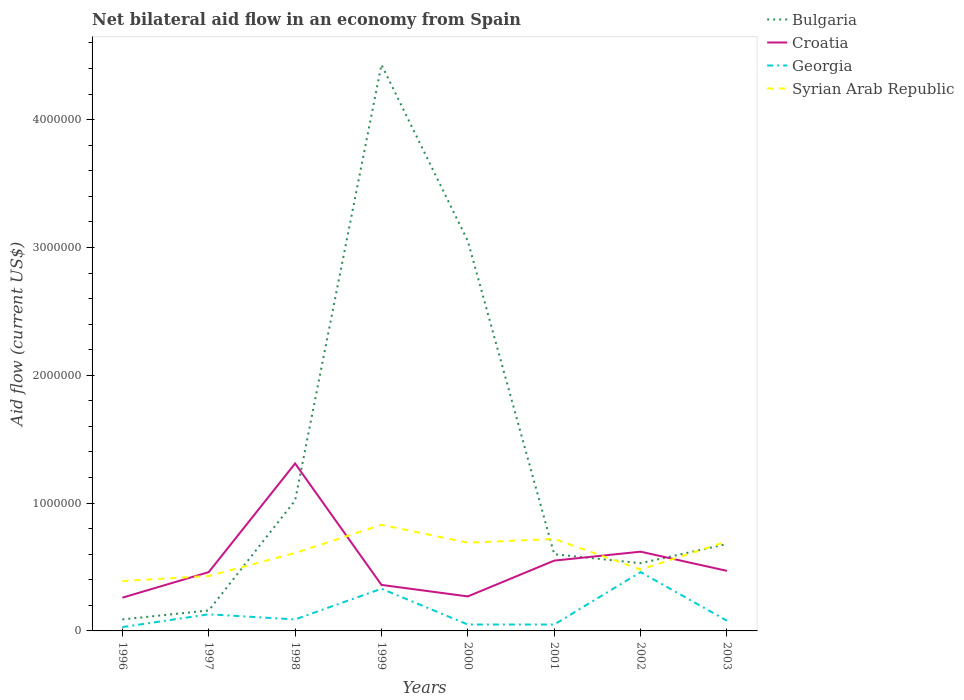Across all years, what is the maximum net bilateral aid flow in Bulgaria?
Ensure brevity in your answer.  9.00e+04. What is the difference between the highest and the second highest net bilateral aid flow in Bulgaria?
Provide a short and direct response. 4.34e+06. Is the net bilateral aid flow in Croatia strictly greater than the net bilateral aid flow in Syrian Arab Republic over the years?
Ensure brevity in your answer.  No. How many years are there in the graph?
Offer a very short reply. 8. Are the values on the major ticks of Y-axis written in scientific E-notation?
Keep it short and to the point. No. Does the graph contain any zero values?
Make the answer very short. No. Does the graph contain grids?
Provide a succinct answer. No. Where does the legend appear in the graph?
Offer a very short reply. Top right. How many legend labels are there?
Give a very brief answer. 4. How are the legend labels stacked?
Keep it short and to the point. Vertical. What is the title of the graph?
Keep it short and to the point. Net bilateral aid flow in an economy from Spain. Does "Middle income" appear as one of the legend labels in the graph?
Make the answer very short. No. What is the Aid flow (current US$) in Bulgaria in 1996?
Make the answer very short. 9.00e+04. What is the Aid flow (current US$) of Croatia in 1996?
Provide a short and direct response. 2.60e+05. What is the Aid flow (current US$) in Bulgaria in 1997?
Keep it short and to the point. 1.60e+05. What is the Aid flow (current US$) in Croatia in 1997?
Provide a short and direct response. 4.60e+05. What is the Aid flow (current US$) in Georgia in 1997?
Ensure brevity in your answer.  1.30e+05. What is the Aid flow (current US$) of Syrian Arab Republic in 1997?
Provide a short and direct response. 4.30e+05. What is the Aid flow (current US$) in Bulgaria in 1998?
Ensure brevity in your answer.  1.02e+06. What is the Aid flow (current US$) in Croatia in 1998?
Make the answer very short. 1.31e+06. What is the Aid flow (current US$) in Georgia in 1998?
Your answer should be very brief. 9.00e+04. What is the Aid flow (current US$) in Bulgaria in 1999?
Provide a short and direct response. 4.43e+06. What is the Aid flow (current US$) of Syrian Arab Republic in 1999?
Offer a very short reply. 8.30e+05. What is the Aid flow (current US$) of Bulgaria in 2000?
Make the answer very short. 3.05e+06. What is the Aid flow (current US$) in Croatia in 2000?
Offer a terse response. 2.70e+05. What is the Aid flow (current US$) in Syrian Arab Republic in 2000?
Ensure brevity in your answer.  6.90e+05. What is the Aid flow (current US$) of Georgia in 2001?
Make the answer very short. 5.00e+04. What is the Aid flow (current US$) of Syrian Arab Republic in 2001?
Offer a very short reply. 7.20e+05. What is the Aid flow (current US$) of Bulgaria in 2002?
Offer a terse response. 5.30e+05. What is the Aid flow (current US$) of Croatia in 2002?
Give a very brief answer. 6.20e+05. What is the Aid flow (current US$) in Georgia in 2002?
Offer a terse response. 4.60e+05. What is the Aid flow (current US$) of Syrian Arab Republic in 2002?
Your answer should be compact. 4.80e+05. What is the Aid flow (current US$) of Bulgaria in 2003?
Give a very brief answer. 6.80e+05. What is the Aid flow (current US$) in Croatia in 2003?
Ensure brevity in your answer.  4.70e+05. What is the Aid flow (current US$) in Georgia in 2003?
Your response must be concise. 8.00e+04. Across all years, what is the maximum Aid flow (current US$) in Bulgaria?
Provide a succinct answer. 4.43e+06. Across all years, what is the maximum Aid flow (current US$) of Croatia?
Give a very brief answer. 1.31e+06. Across all years, what is the maximum Aid flow (current US$) in Syrian Arab Republic?
Keep it short and to the point. 8.30e+05. Across all years, what is the minimum Aid flow (current US$) in Croatia?
Keep it short and to the point. 2.60e+05. Across all years, what is the minimum Aid flow (current US$) in Georgia?
Your response must be concise. 3.00e+04. What is the total Aid flow (current US$) in Bulgaria in the graph?
Keep it short and to the point. 1.06e+07. What is the total Aid flow (current US$) in Croatia in the graph?
Offer a terse response. 4.30e+06. What is the total Aid flow (current US$) in Georgia in the graph?
Your answer should be very brief. 1.22e+06. What is the total Aid flow (current US$) in Syrian Arab Republic in the graph?
Keep it short and to the point. 4.85e+06. What is the difference between the Aid flow (current US$) of Bulgaria in 1996 and that in 1997?
Provide a succinct answer. -7.00e+04. What is the difference between the Aid flow (current US$) in Croatia in 1996 and that in 1997?
Provide a succinct answer. -2.00e+05. What is the difference between the Aid flow (current US$) in Georgia in 1996 and that in 1997?
Offer a terse response. -1.00e+05. What is the difference between the Aid flow (current US$) in Syrian Arab Republic in 1996 and that in 1997?
Provide a succinct answer. -4.00e+04. What is the difference between the Aid flow (current US$) of Bulgaria in 1996 and that in 1998?
Ensure brevity in your answer.  -9.30e+05. What is the difference between the Aid flow (current US$) of Croatia in 1996 and that in 1998?
Offer a very short reply. -1.05e+06. What is the difference between the Aid flow (current US$) of Bulgaria in 1996 and that in 1999?
Offer a terse response. -4.34e+06. What is the difference between the Aid flow (current US$) in Syrian Arab Republic in 1996 and that in 1999?
Ensure brevity in your answer.  -4.40e+05. What is the difference between the Aid flow (current US$) of Bulgaria in 1996 and that in 2000?
Provide a short and direct response. -2.96e+06. What is the difference between the Aid flow (current US$) of Georgia in 1996 and that in 2000?
Your answer should be compact. -2.00e+04. What is the difference between the Aid flow (current US$) in Bulgaria in 1996 and that in 2001?
Ensure brevity in your answer.  -5.10e+05. What is the difference between the Aid flow (current US$) in Croatia in 1996 and that in 2001?
Give a very brief answer. -2.90e+05. What is the difference between the Aid flow (current US$) of Georgia in 1996 and that in 2001?
Keep it short and to the point. -2.00e+04. What is the difference between the Aid flow (current US$) of Syrian Arab Republic in 1996 and that in 2001?
Offer a terse response. -3.30e+05. What is the difference between the Aid flow (current US$) in Bulgaria in 1996 and that in 2002?
Provide a short and direct response. -4.40e+05. What is the difference between the Aid flow (current US$) of Croatia in 1996 and that in 2002?
Offer a very short reply. -3.60e+05. What is the difference between the Aid flow (current US$) of Georgia in 1996 and that in 2002?
Your answer should be compact. -4.30e+05. What is the difference between the Aid flow (current US$) of Bulgaria in 1996 and that in 2003?
Your answer should be very brief. -5.90e+05. What is the difference between the Aid flow (current US$) in Syrian Arab Republic in 1996 and that in 2003?
Your answer should be very brief. -3.10e+05. What is the difference between the Aid flow (current US$) of Bulgaria in 1997 and that in 1998?
Give a very brief answer. -8.60e+05. What is the difference between the Aid flow (current US$) in Croatia in 1997 and that in 1998?
Ensure brevity in your answer.  -8.50e+05. What is the difference between the Aid flow (current US$) in Bulgaria in 1997 and that in 1999?
Your response must be concise. -4.27e+06. What is the difference between the Aid flow (current US$) of Croatia in 1997 and that in 1999?
Ensure brevity in your answer.  1.00e+05. What is the difference between the Aid flow (current US$) in Syrian Arab Republic in 1997 and that in 1999?
Provide a short and direct response. -4.00e+05. What is the difference between the Aid flow (current US$) of Bulgaria in 1997 and that in 2000?
Provide a short and direct response. -2.89e+06. What is the difference between the Aid flow (current US$) in Croatia in 1997 and that in 2000?
Offer a terse response. 1.90e+05. What is the difference between the Aid flow (current US$) of Georgia in 1997 and that in 2000?
Ensure brevity in your answer.  8.00e+04. What is the difference between the Aid flow (current US$) of Bulgaria in 1997 and that in 2001?
Your answer should be compact. -4.40e+05. What is the difference between the Aid flow (current US$) in Syrian Arab Republic in 1997 and that in 2001?
Offer a terse response. -2.90e+05. What is the difference between the Aid flow (current US$) of Bulgaria in 1997 and that in 2002?
Ensure brevity in your answer.  -3.70e+05. What is the difference between the Aid flow (current US$) in Georgia in 1997 and that in 2002?
Offer a very short reply. -3.30e+05. What is the difference between the Aid flow (current US$) in Bulgaria in 1997 and that in 2003?
Your response must be concise. -5.20e+05. What is the difference between the Aid flow (current US$) of Croatia in 1997 and that in 2003?
Provide a short and direct response. -10000. What is the difference between the Aid flow (current US$) of Syrian Arab Republic in 1997 and that in 2003?
Provide a succinct answer. -2.70e+05. What is the difference between the Aid flow (current US$) of Bulgaria in 1998 and that in 1999?
Your answer should be compact. -3.41e+06. What is the difference between the Aid flow (current US$) in Croatia in 1998 and that in 1999?
Make the answer very short. 9.50e+05. What is the difference between the Aid flow (current US$) in Bulgaria in 1998 and that in 2000?
Give a very brief answer. -2.03e+06. What is the difference between the Aid flow (current US$) of Croatia in 1998 and that in 2000?
Ensure brevity in your answer.  1.04e+06. What is the difference between the Aid flow (current US$) in Georgia in 1998 and that in 2000?
Ensure brevity in your answer.  4.00e+04. What is the difference between the Aid flow (current US$) in Syrian Arab Republic in 1998 and that in 2000?
Ensure brevity in your answer.  -8.00e+04. What is the difference between the Aid flow (current US$) in Croatia in 1998 and that in 2001?
Your answer should be compact. 7.60e+05. What is the difference between the Aid flow (current US$) in Georgia in 1998 and that in 2001?
Give a very brief answer. 4.00e+04. What is the difference between the Aid flow (current US$) in Croatia in 1998 and that in 2002?
Provide a succinct answer. 6.90e+05. What is the difference between the Aid flow (current US$) of Georgia in 1998 and that in 2002?
Offer a very short reply. -3.70e+05. What is the difference between the Aid flow (current US$) in Bulgaria in 1998 and that in 2003?
Keep it short and to the point. 3.40e+05. What is the difference between the Aid flow (current US$) in Croatia in 1998 and that in 2003?
Ensure brevity in your answer.  8.40e+05. What is the difference between the Aid flow (current US$) of Syrian Arab Republic in 1998 and that in 2003?
Your response must be concise. -9.00e+04. What is the difference between the Aid flow (current US$) of Bulgaria in 1999 and that in 2000?
Give a very brief answer. 1.38e+06. What is the difference between the Aid flow (current US$) of Georgia in 1999 and that in 2000?
Ensure brevity in your answer.  2.80e+05. What is the difference between the Aid flow (current US$) in Syrian Arab Republic in 1999 and that in 2000?
Offer a terse response. 1.40e+05. What is the difference between the Aid flow (current US$) of Bulgaria in 1999 and that in 2001?
Your response must be concise. 3.83e+06. What is the difference between the Aid flow (current US$) in Croatia in 1999 and that in 2001?
Make the answer very short. -1.90e+05. What is the difference between the Aid flow (current US$) in Syrian Arab Republic in 1999 and that in 2001?
Offer a very short reply. 1.10e+05. What is the difference between the Aid flow (current US$) of Bulgaria in 1999 and that in 2002?
Your answer should be very brief. 3.90e+06. What is the difference between the Aid flow (current US$) of Croatia in 1999 and that in 2002?
Make the answer very short. -2.60e+05. What is the difference between the Aid flow (current US$) in Georgia in 1999 and that in 2002?
Your response must be concise. -1.30e+05. What is the difference between the Aid flow (current US$) in Syrian Arab Republic in 1999 and that in 2002?
Give a very brief answer. 3.50e+05. What is the difference between the Aid flow (current US$) of Bulgaria in 1999 and that in 2003?
Your answer should be very brief. 3.75e+06. What is the difference between the Aid flow (current US$) in Syrian Arab Republic in 1999 and that in 2003?
Provide a succinct answer. 1.30e+05. What is the difference between the Aid flow (current US$) in Bulgaria in 2000 and that in 2001?
Keep it short and to the point. 2.45e+06. What is the difference between the Aid flow (current US$) in Croatia in 2000 and that in 2001?
Provide a succinct answer. -2.80e+05. What is the difference between the Aid flow (current US$) in Georgia in 2000 and that in 2001?
Offer a very short reply. 0. What is the difference between the Aid flow (current US$) in Bulgaria in 2000 and that in 2002?
Offer a very short reply. 2.52e+06. What is the difference between the Aid flow (current US$) of Croatia in 2000 and that in 2002?
Provide a succinct answer. -3.50e+05. What is the difference between the Aid flow (current US$) in Georgia in 2000 and that in 2002?
Your answer should be compact. -4.10e+05. What is the difference between the Aid flow (current US$) in Bulgaria in 2000 and that in 2003?
Your answer should be very brief. 2.37e+06. What is the difference between the Aid flow (current US$) of Georgia in 2000 and that in 2003?
Your response must be concise. -3.00e+04. What is the difference between the Aid flow (current US$) in Syrian Arab Republic in 2000 and that in 2003?
Provide a short and direct response. -10000. What is the difference between the Aid flow (current US$) in Bulgaria in 2001 and that in 2002?
Ensure brevity in your answer.  7.00e+04. What is the difference between the Aid flow (current US$) in Croatia in 2001 and that in 2002?
Keep it short and to the point. -7.00e+04. What is the difference between the Aid flow (current US$) in Georgia in 2001 and that in 2002?
Offer a very short reply. -4.10e+05. What is the difference between the Aid flow (current US$) of Syrian Arab Republic in 2001 and that in 2002?
Your response must be concise. 2.40e+05. What is the difference between the Aid flow (current US$) of Georgia in 2001 and that in 2003?
Give a very brief answer. -3.00e+04. What is the difference between the Aid flow (current US$) of Syrian Arab Republic in 2001 and that in 2003?
Ensure brevity in your answer.  2.00e+04. What is the difference between the Aid flow (current US$) of Bulgaria in 2002 and that in 2003?
Keep it short and to the point. -1.50e+05. What is the difference between the Aid flow (current US$) in Georgia in 2002 and that in 2003?
Your response must be concise. 3.80e+05. What is the difference between the Aid flow (current US$) of Syrian Arab Republic in 2002 and that in 2003?
Your answer should be very brief. -2.20e+05. What is the difference between the Aid flow (current US$) of Bulgaria in 1996 and the Aid flow (current US$) of Croatia in 1997?
Keep it short and to the point. -3.70e+05. What is the difference between the Aid flow (current US$) in Bulgaria in 1996 and the Aid flow (current US$) in Georgia in 1997?
Keep it short and to the point. -4.00e+04. What is the difference between the Aid flow (current US$) in Croatia in 1996 and the Aid flow (current US$) in Georgia in 1997?
Provide a short and direct response. 1.30e+05. What is the difference between the Aid flow (current US$) of Georgia in 1996 and the Aid flow (current US$) of Syrian Arab Republic in 1997?
Keep it short and to the point. -4.00e+05. What is the difference between the Aid flow (current US$) in Bulgaria in 1996 and the Aid flow (current US$) in Croatia in 1998?
Offer a terse response. -1.22e+06. What is the difference between the Aid flow (current US$) of Bulgaria in 1996 and the Aid flow (current US$) of Syrian Arab Republic in 1998?
Offer a terse response. -5.20e+05. What is the difference between the Aid flow (current US$) in Croatia in 1996 and the Aid flow (current US$) in Georgia in 1998?
Offer a terse response. 1.70e+05. What is the difference between the Aid flow (current US$) in Croatia in 1996 and the Aid flow (current US$) in Syrian Arab Republic in 1998?
Offer a terse response. -3.50e+05. What is the difference between the Aid flow (current US$) of Georgia in 1996 and the Aid flow (current US$) of Syrian Arab Republic in 1998?
Keep it short and to the point. -5.80e+05. What is the difference between the Aid flow (current US$) of Bulgaria in 1996 and the Aid flow (current US$) of Croatia in 1999?
Offer a terse response. -2.70e+05. What is the difference between the Aid flow (current US$) in Bulgaria in 1996 and the Aid flow (current US$) in Syrian Arab Republic in 1999?
Your response must be concise. -7.40e+05. What is the difference between the Aid flow (current US$) of Croatia in 1996 and the Aid flow (current US$) of Georgia in 1999?
Your answer should be compact. -7.00e+04. What is the difference between the Aid flow (current US$) in Croatia in 1996 and the Aid flow (current US$) in Syrian Arab Republic in 1999?
Ensure brevity in your answer.  -5.70e+05. What is the difference between the Aid flow (current US$) of Georgia in 1996 and the Aid flow (current US$) of Syrian Arab Republic in 1999?
Provide a short and direct response. -8.00e+05. What is the difference between the Aid flow (current US$) in Bulgaria in 1996 and the Aid flow (current US$) in Syrian Arab Republic in 2000?
Offer a terse response. -6.00e+05. What is the difference between the Aid flow (current US$) in Croatia in 1996 and the Aid flow (current US$) in Syrian Arab Republic in 2000?
Your response must be concise. -4.30e+05. What is the difference between the Aid flow (current US$) of Georgia in 1996 and the Aid flow (current US$) of Syrian Arab Republic in 2000?
Your answer should be compact. -6.60e+05. What is the difference between the Aid flow (current US$) of Bulgaria in 1996 and the Aid flow (current US$) of Croatia in 2001?
Ensure brevity in your answer.  -4.60e+05. What is the difference between the Aid flow (current US$) of Bulgaria in 1996 and the Aid flow (current US$) of Syrian Arab Republic in 2001?
Offer a terse response. -6.30e+05. What is the difference between the Aid flow (current US$) in Croatia in 1996 and the Aid flow (current US$) in Syrian Arab Republic in 2001?
Your answer should be very brief. -4.60e+05. What is the difference between the Aid flow (current US$) in Georgia in 1996 and the Aid flow (current US$) in Syrian Arab Republic in 2001?
Provide a succinct answer. -6.90e+05. What is the difference between the Aid flow (current US$) in Bulgaria in 1996 and the Aid flow (current US$) in Croatia in 2002?
Your response must be concise. -5.30e+05. What is the difference between the Aid flow (current US$) in Bulgaria in 1996 and the Aid flow (current US$) in Georgia in 2002?
Your answer should be compact. -3.70e+05. What is the difference between the Aid flow (current US$) in Bulgaria in 1996 and the Aid flow (current US$) in Syrian Arab Republic in 2002?
Your answer should be compact. -3.90e+05. What is the difference between the Aid flow (current US$) in Croatia in 1996 and the Aid flow (current US$) in Georgia in 2002?
Keep it short and to the point. -2.00e+05. What is the difference between the Aid flow (current US$) in Georgia in 1996 and the Aid flow (current US$) in Syrian Arab Republic in 2002?
Your response must be concise. -4.50e+05. What is the difference between the Aid flow (current US$) in Bulgaria in 1996 and the Aid flow (current US$) in Croatia in 2003?
Keep it short and to the point. -3.80e+05. What is the difference between the Aid flow (current US$) of Bulgaria in 1996 and the Aid flow (current US$) of Georgia in 2003?
Provide a succinct answer. 10000. What is the difference between the Aid flow (current US$) of Bulgaria in 1996 and the Aid flow (current US$) of Syrian Arab Republic in 2003?
Offer a terse response. -6.10e+05. What is the difference between the Aid flow (current US$) in Croatia in 1996 and the Aid flow (current US$) in Georgia in 2003?
Give a very brief answer. 1.80e+05. What is the difference between the Aid flow (current US$) in Croatia in 1996 and the Aid flow (current US$) in Syrian Arab Republic in 2003?
Your response must be concise. -4.40e+05. What is the difference between the Aid flow (current US$) in Georgia in 1996 and the Aid flow (current US$) in Syrian Arab Republic in 2003?
Provide a succinct answer. -6.70e+05. What is the difference between the Aid flow (current US$) in Bulgaria in 1997 and the Aid flow (current US$) in Croatia in 1998?
Provide a short and direct response. -1.15e+06. What is the difference between the Aid flow (current US$) of Bulgaria in 1997 and the Aid flow (current US$) of Syrian Arab Republic in 1998?
Make the answer very short. -4.50e+05. What is the difference between the Aid flow (current US$) in Croatia in 1997 and the Aid flow (current US$) in Syrian Arab Republic in 1998?
Provide a succinct answer. -1.50e+05. What is the difference between the Aid flow (current US$) in Georgia in 1997 and the Aid flow (current US$) in Syrian Arab Republic in 1998?
Keep it short and to the point. -4.80e+05. What is the difference between the Aid flow (current US$) of Bulgaria in 1997 and the Aid flow (current US$) of Croatia in 1999?
Make the answer very short. -2.00e+05. What is the difference between the Aid flow (current US$) of Bulgaria in 1997 and the Aid flow (current US$) of Georgia in 1999?
Provide a short and direct response. -1.70e+05. What is the difference between the Aid flow (current US$) in Bulgaria in 1997 and the Aid flow (current US$) in Syrian Arab Republic in 1999?
Make the answer very short. -6.70e+05. What is the difference between the Aid flow (current US$) in Croatia in 1997 and the Aid flow (current US$) in Georgia in 1999?
Your answer should be compact. 1.30e+05. What is the difference between the Aid flow (current US$) of Croatia in 1997 and the Aid flow (current US$) of Syrian Arab Republic in 1999?
Your response must be concise. -3.70e+05. What is the difference between the Aid flow (current US$) in Georgia in 1997 and the Aid flow (current US$) in Syrian Arab Republic in 1999?
Provide a short and direct response. -7.00e+05. What is the difference between the Aid flow (current US$) of Bulgaria in 1997 and the Aid flow (current US$) of Syrian Arab Republic in 2000?
Make the answer very short. -5.30e+05. What is the difference between the Aid flow (current US$) in Croatia in 1997 and the Aid flow (current US$) in Syrian Arab Republic in 2000?
Give a very brief answer. -2.30e+05. What is the difference between the Aid flow (current US$) in Georgia in 1997 and the Aid flow (current US$) in Syrian Arab Republic in 2000?
Keep it short and to the point. -5.60e+05. What is the difference between the Aid flow (current US$) of Bulgaria in 1997 and the Aid flow (current US$) of Croatia in 2001?
Your response must be concise. -3.90e+05. What is the difference between the Aid flow (current US$) of Bulgaria in 1997 and the Aid flow (current US$) of Syrian Arab Republic in 2001?
Your answer should be very brief. -5.60e+05. What is the difference between the Aid flow (current US$) of Croatia in 1997 and the Aid flow (current US$) of Syrian Arab Republic in 2001?
Provide a short and direct response. -2.60e+05. What is the difference between the Aid flow (current US$) in Georgia in 1997 and the Aid flow (current US$) in Syrian Arab Republic in 2001?
Offer a terse response. -5.90e+05. What is the difference between the Aid flow (current US$) of Bulgaria in 1997 and the Aid flow (current US$) of Croatia in 2002?
Make the answer very short. -4.60e+05. What is the difference between the Aid flow (current US$) of Bulgaria in 1997 and the Aid flow (current US$) of Georgia in 2002?
Your answer should be very brief. -3.00e+05. What is the difference between the Aid flow (current US$) in Bulgaria in 1997 and the Aid flow (current US$) in Syrian Arab Republic in 2002?
Keep it short and to the point. -3.20e+05. What is the difference between the Aid flow (current US$) in Croatia in 1997 and the Aid flow (current US$) in Georgia in 2002?
Ensure brevity in your answer.  0. What is the difference between the Aid flow (current US$) of Croatia in 1997 and the Aid flow (current US$) of Syrian Arab Republic in 2002?
Ensure brevity in your answer.  -2.00e+04. What is the difference between the Aid flow (current US$) of Georgia in 1997 and the Aid flow (current US$) of Syrian Arab Republic in 2002?
Provide a short and direct response. -3.50e+05. What is the difference between the Aid flow (current US$) in Bulgaria in 1997 and the Aid flow (current US$) in Croatia in 2003?
Ensure brevity in your answer.  -3.10e+05. What is the difference between the Aid flow (current US$) of Bulgaria in 1997 and the Aid flow (current US$) of Georgia in 2003?
Your answer should be compact. 8.00e+04. What is the difference between the Aid flow (current US$) in Bulgaria in 1997 and the Aid flow (current US$) in Syrian Arab Republic in 2003?
Provide a succinct answer. -5.40e+05. What is the difference between the Aid flow (current US$) in Croatia in 1997 and the Aid flow (current US$) in Syrian Arab Republic in 2003?
Your answer should be very brief. -2.40e+05. What is the difference between the Aid flow (current US$) in Georgia in 1997 and the Aid flow (current US$) in Syrian Arab Republic in 2003?
Give a very brief answer. -5.70e+05. What is the difference between the Aid flow (current US$) in Bulgaria in 1998 and the Aid flow (current US$) in Croatia in 1999?
Your response must be concise. 6.60e+05. What is the difference between the Aid flow (current US$) in Bulgaria in 1998 and the Aid flow (current US$) in Georgia in 1999?
Your answer should be very brief. 6.90e+05. What is the difference between the Aid flow (current US$) of Bulgaria in 1998 and the Aid flow (current US$) of Syrian Arab Republic in 1999?
Your response must be concise. 1.90e+05. What is the difference between the Aid flow (current US$) of Croatia in 1998 and the Aid flow (current US$) of Georgia in 1999?
Your answer should be compact. 9.80e+05. What is the difference between the Aid flow (current US$) of Croatia in 1998 and the Aid flow (current US$) of Syrian Arab Republic in 1999?
Offer a very short reply. 4.80e+05. What is the difference between the Aid flow (current US$) of Georgia in 1998 and the Aid flow (current US$) of Syrian Arab Republic in 1999?
Provide a succinct answer. -7.40e+05. What is the difference between the Aid flow (current US$) of Bulgaria in 1998 and the Aid flow (current US$) of Croatia in 2000?
Offer a very short reply. 7.50e+05. What is the difference between the Aid flow (current US$) in Bulgaria in 1998 and the Aid flow (current US$) in Georgia in 2000?
Your answer should be very brief. 9.70e+05. What is the difference between the Aid flow (current US$) of Bulgaria in 1998 and the Aid flow (current US$) of Syrian Arab Republic in 2000?
Offer a terse response. 3.30e+05. What is the difference between the Aid flow (current US$) of Croatia in 1998 and the Aid flow (current US$) of Georgia in 2000?
Provide a succinct answer. 1.26e+06. What is the difference between the Aid flow (current US$) in Croatia in 1998 and the Aid flow (current US$) in Syrian Arab Republic in 2000?
Provide a short and direct response. 6.20e+05. What is the difference between the Aid flow (current US$) of Georgia in 1998 and the Aid flow (current US$) of Syrian Arab Republic in 2000?
Provide a short and direct response. -6.00e+05. What is the difference between the Aid flow (current US$) of Bulgaria in 1998 and the Aid flow (current US$) of Georgia in 2001?
Offer a very short reply. 9.70e+05. What is the difference between the Aid flow (current US$) of Bulgaria in 1998 and the Aid flow (current US$) of Syrian Arab Republic in 2001?
Provide a succinct answer. 3.00e+05. What is the difference between the Aid flow (current US$) in Croatia in 1998 and the Aid flow (current US$) in Georgia in 2001?
Offer a terse response. 1.26e+06. What is the difference between the Aid flow (current US$) in Croatia in 1998 and the Aid flow (current US$) in Syrian Arab Republic in 2001?
Ensure brevity in your answer.  5.90e+05. What is the difference between the Aid flow (current US$) of Georgia in 1998 and the Aid flow (current US$) of Syrian Arab Republic in 2001?
Make the answer very short. -6.30e+05. What is the difference between the Aid flow (current US$) in Bulgaria in 1998 and the Aid flow (current US$) in Croatia in 2002?
Provide a succinct answer. 4.00e+05. What is the difference between the Aid flow (current US$) of Bulgaria in 1998 and the Aid flow (current US$) of Georgia in 2002?
Your answer should be very brief. 5.60e+05. What is the difference between the Aid flow (current US$) of Bulgaria in 1998 and the Aid flow (current US$) of Syrian Arab Republic in 2002?
Provide a succinct answer. 5.40e+05. What is the difference between the Aid flow (current US$) of Croatia in 1998 and the Aid flow (current US$) of Georgia in 2002?
Keep it short and to the point. 8.50e+05. What is the difference between the Aid flow (current US$) of Croatia in 1998 and the Aid flow (current US$) of Syrian Arab Republic in 2002?
Make the answer very short. 8.30e+05. What is the difference between the Aid flow (current US$) in Georgia in 1998 and the Aid flow (current US$) in Syrian Arab Republic in 2002?
Keep it short and to the point. -3.90e+05. What is the difference between the Aid flow (current US$) of Bulgaria in 1998 and the Aid flow (current US$) of Croatia in 2003?
Offer a terse response. 5.50e+05. What is the difference between the Aid flow (current US$) in Bulgaria in 1998 and the Aid flow (current US$) in Georgia in 2003?
Provide a short and direct response. 9.40e+05. What is the difference between the Aid flow (current US$) of Croatia in 1998 and the Aid flow (current US$) of Georgia in 2003?
Your answer should be very brief. 1.23e+06. What is the difference between the Aid flow (current US$) of Croatia in 1998 and the Aid flow (current US$) of Syrian Arab Republic in 2003?
Keep it short and to the point. 6.10e+05. What is the difference between the Aid flow (current US$) of Georgia in 1998 and the Aid flow (current US$) of Syrian Arab Republic in 2003?
Ensure brevity in your answer.  -6.10e+05. What is the difference between the Aid flow (current US$) in Bulgaria in 1999 and the Aid flow (current US$) in Croatia in 2000?
Your answer should be very brief. 4.16e+06. What is the difference between the Aid flow (current US$) of Bulgaria in 1999 and the Aid flow (current US$) of Georgia in 2000?
Keep it short and to the point. 4.38e+06. What is the difference between the Aid flow (current US$) of Bulgaria in 1999 and the Aid flow (current US$) of Syrian Arab Republic in 2000?
Keep it short and to the point. 3.74e+06. What is the difference between the Aid flow (current US$) in Croatia in 1999 and the Aid flow (current US$) in Syrian Arab Republic in 2000?
Your answer should be compact. -3.30e+05. What is the difference between the Aid flow (current US$) of Georgia in 1999 and the Aid flow (current US$) of Syrian Arab Republic in 2000?
Ensure brevity in your answer.  -3.60e+05. What is the difference between the Aid flow (current US$) in Bulgaria in 1999 and the Aid flow (current US$) in Croatia in 2001?
Keep it short and to the point. 3.88e+06. What is the difference between the Aid flow (current US$) in Bulgaria in 1999 and the Aid flow (current US$) in Georgia in 2001?
Offer a very short reply. 4.38e+06. What is the difference between the Aid flow (current US$) in Bulgaria in 1999 and the Aid flow (current US$) in Syrian Arab Republic in 2001?
Provide a short and direct response. 3.71e+06. What is the difference between the Aid flow (current US$) of Croatia in 1999 and the Aid flow (current US$) of Syrian Arab Republic in 2001?
Make the answer very short. -3.60e+05. What is the difference between the Aid flow (current US$) in Georgia in 1999 and the Aid flow (current US$) in Syrian Arab Republic in 2001?
Your answer should be very brief. -3.90e+05. What is the difference between the Aid flow (current US$) of Bulgaria in 1999 and the Aid flow (current US$) of Croatia in 2002?
Your response must be concise. 3.81e+06. What is the difference between the Aid flow (current US$) in Bulgaria in 1999 and the Aid flow (current US$) in Georgia in 2002?
Keep it short and to the point. 3.97e+06. What is the difference between the Aid flow (current US$) of Bulgaria in 1999 and the Aid flow (current US$) of Syrian Arab Republic in 2002?
Offer a very short reply. 3.95e+06. What is the difference between the Aid flow (current US$) of Croatia in 1999 and the Aid flow (current US$) of Georgia in 2002?
Provide a short and direct response. -1.00e+05. What is the difference between the Aid flow (current US$) of Croatia in 1999 and the Aid flow (current US$) of Syrian Arab Republic in 2002?
Provide a succinct answer. -1.20e+05. What is the difference between the Aid flow (current US$) in Bulgaria in 1999 and the Aid flow (current US$) in Croatia in 2003?
Give a very brief answer. 3.96e+06. What is the difference between the Aid flow (current US$) of Bulgaria in 1999 and the Aid flow (current US$) of Georgia in 2003?
Keep it short and to the point. 4.35e+06. What is the difference between the Aid flow (current US$) of Bulgaria in 1999 and the Aid flow (current US$) of Syrian Arab Republic in 2003?
Offer a terse response. 3.73e+06. What is the difference between the Aid flow (current US$) of Croatia in 1999 and the Aid flow (current US$) of Georgia in 2003?
Ensure brevity in your answer.  2.80e+05. What is the difference between the Aid flow (current US$) in Georgia in 1999 and the Aid flow (current US$) in Syrian Arab Republic in 2003?
Make the answer very short. -3.70e+05. What is the difference between the Aid flow (current US$) of Bulgaria in 2000 and the Aid flow (current US$) of Croatia in 2001?
Give a very brief answer. 2.50e+06. What is the difference between the Aid flow (current US$) in Bulgaria in 2000 and the Aid flow (current US$) in Georgia in 2001?
Ensure brevity in your answer.  3.00e+06. What is the difference between the Aid flow (current US$) in Bulgaria in 2000 and the Aid flow (current US$) in Syrian Arab Republic in 2001?
Offer a very short reply. 2.33e+06. What is the difference between the Aid flow (current US$) in Croatia in 2000 and the Aid flow (current US$) in Georgia in 2001?
Make the answer very short. 2.20e+05. What is the difference between the Aid flow (current US$) of Croatia in 2000 and the Aid flow (current US$) of Syrian Arab Republic in 2001?
Offer a terse response. -4.50e+05. What is the difference between the Aid flow (current US$) in Georgia in 2000 and the Aid flow (current US$) in Syrian Arab Republic in 2001?
Give a very brief answer. -6.70e+05. What is the difference between the Aid flow (current US$) of Bulgaria in 2000 and the Aid flow (current US$) of Croatia in 2002?
Your answer should be very brief. 2.43e+06. What is the difference between the Aid flow (current US$) of Bulgaria in 2000 and the Aid flow (current US$) of Georgia in 2002?
Ensure brevity in your answer.  2.59e+06. What is the difference between the Aid flow (current US$) in Bulgaria in 2000 and the Aid flow (current US$) in Syrian Arab Republic in 2002?
Provide a short and direct response. 2.57e+06. What is the difference between the Aid flow (current US$) of Georgia in 2000 and the Aid flow (current US$) of Syrian Arab Republic in 2002?
Offer a terse response. -4.30e+05. What is the difference between the Aid flow (current US$) of Bulgaria in 2000 and the Aid flow (current US$) of Croatia in 2003?
Give a very brief answer. 2.58e+06. What is the difference between the Aid flow (current US$) in Bulgaria in 2000 and the Aid flow (current US$) in Georgia in 2003?
Provide a short and direct response. 2.97e+06. What is the difference between the Aid flow (current US$) in Bulgaria in 2000 and the Aid flow (current US$) in Syrian Arab Republic in 2003?
Give a very brief answer. 2.35e+06. What is the difference between the Aid flow (current US$) in Croatia in 2000 and the Aid flow (current US$) in Syrian Arab Republic in 2003?
Keep it short and to the point. -4.30e+05. What is the difference between the Aid flow (current US$) of Georgia in 2000 and the Aid flow (current US$) of Syrian Arab Republic in 2003?
Offer a very short reply. -6.50e+05. What is the difference between the Aid flow (current US$) of Georgia in 2001 and the Aid flow (current US$) of Syrian Arab Republic in 2002?
Give a very brief answer. -4.30e+05. What is the difference between the Aid flow (current US$) of Bulgaria in 2001 and the Aid flow (current US$) of Croatia in 2003?
Ensure brevity in your answer.  1.30e+05. What is the difference between the Aid flow (current US$) in Bulgaria in 2001 and the Aid flow (current US$) in Georgia in 2003?
Give a very brief answer. 5.20e+05. What is the difference between the Aid flow (current US$) in Croatia in 2001 and the Aid flow (current US$) in Georgia in 2003?
Your answer should be compact. 4.70e+05. What is the difference between the Aid flow (current US$) of Croatia in 2001 and the Aid flow (current US$) of Syrian Arab Republic in 2003?
Keep it short and to the point. -1.50e+05. What is the difference between the Aid flow (current US$) of Georgia in 2001 and the Aid flow (current US$) of Syrian Arab Republic in 2003?
Your answer should be compact. -6.50e+05. What is the difference between the Aid flow (current US$) of Bulgaria in 2002 and the Aid flow (current US$) of Croatia in 2003?
Offer a terse response. 6.00e+04. What is the difference between the Aid flow (current US$) in Bulgaria in 2002 and the Aid flow (current US$) in Georgia in 2003?
Offer a terse response. 4.50e+05. What is the difference between the Aid flow (current US$) in Bulgaria in 2002 and the Aid flow (current US$) in Syrian Arab Republic in 2003?
Ensure brevity in your answer.  -1.70e+05. What is the difference between the Aid flow (current US$) of Croatia in 2002 and the Aid flow (current US$) of Georgia in 2003?
Your answer should be compact. 5.40e+05. What is the average Aid flow (current US$) of Bulgaria per year?
Offer a terse response. 1.32e+06. What is the average Aid flow (current US$) of Croatia per year?
Your response must be concise. 5.38e+05. What is the average Aid flow (current US$) in Georgia per year?
Give a very brief answer. 1.52e+05. What is the average Aid flow (current US$) in Syrian Arab Republic per year?
Your response must be concise. 6.06e+05. In the year 1996, what is the difference between the Aid flow (current US$) of Bulgaria and Aid flow (current US$) of Croatia?
Ensure brevity in your answer.  -1.70e+05. In the year 1996, what is the difference between the Aid flow (current US$) of Bulgaria and Aid flow (current US$) of Georgia?
Give a very brief answer. 6.00e+04. In the year 1996, what is the difference between the Aid flow (current US$) in Croatia and Aid flow (current US$) in Syrian Arab Republic?
Offer a very short reply. -1.30e+05. In the year 1996, what is the difference between the Aid flow (current US$) in Georgia and Aid flow (current US$) in Syrian Arab Republic?
Provide a succinct answer. -3.60e+05. In the year 1997, what is the difference between the Aid flow (current US$) of Bulgaria and Aid flow (current US$) of Croatia?
Offer a very short reply. -3.00e+05. In the year 1997, what is the difference between the Aid flow (current US$) of Bulgaria and Aid flow (current US$) of Syrian Arab Republic?
Your answer should be compact. -2.70e+05. In the year 1997, what is the difference between the Aid flow (current US$) in Croatia and Aid flow (current US$) in Georgia?
Give a very brief answer. 3.30e+05. In the year 1998, what is the difference between the Aid flow (current US$) of Bulgaria and Aid flow (current US$) of Croatia?
Provide a short and direct response. -2.90e+05. In the year 1998, what is the difference between the Aid flow (current US$) of Bulgaria and Aid flow (current US$) of Georgia?
Make the answer very short. 9.30e+05. In the year 1998, what is the difference between the Aid flow (current US$) of Bulgaria and Aid flow (current US$) of Syrian Arab Republic?
Provide a succinct answer. 4.10e+05. In the year 1998, what is the difference between the Aid flow (current US$) in Croatia and Aid flow (current US$) in Georgia?
Make the answer very short. 1.22e+06. In the year 1998, what is the difference between the Aid flow (current US$) of Georgia and Aid flow (current US$) of Syrian Arab Republic?
Make the answer very short. -5.20e+05. In the year 1999, what is the difference between the Aid flow (current US$) in Bulgaria and Aid flow (current US$) in Croatia?
Offer a terse response. 4.07e+06. In the year 1999, what is the difference between the Aid flow (current US$) in Bulgaria and Aid flow (current US$) in Georgia?
Provide a short and direct response. 4.10e+06. In the year 1999, what is the difference between the Aid flow (current US$) in Bulgaria and Aid flow (current US$) in Syrian Arab Republic?
Make the answer very short. 3.60e+06. In the year 1999, what is the difference between the Aid flow (current US$) in Croatia and Aid flow (current US$) in Syrian Arab Republic?
Give a very brief answer. -4.70e+05. In the year 1999, what is the difference between the Aid flow (current US$) of Georgia and Aid flow (current US$) of Syrian Arab Republic?
Your response must be concise. -5.00e+05. In the year 2000, what is the difference between the Aid flow (current US$) of Bulgaria and Aid flow (current US$) of Croatia?
Your answer should be very brief. 2.78e+06. In the year 2000, what is the difference between the Aid flow (current US$) in Bulgaria and Aid flow (current US$) in Georgia?
Offer a terse response. 3.00e+06. In the year 2000, what is the difference between the Aid flow (current US$) of Bulgaria and Aid flow (current US$) of Syrian Arab Republic?
Provide a succinct answer. 2.36e+06. In the year 2000, what is the difference between the Aid flow (current US$) of Croatia and Aid flow (current US$) of Syrian Arab Republic?
Offer a terse response. -4.20e+05. In the year 2000, what is the difference between the Aid flow (current US$) of Georgia and Aid flow (current US$) of Syrian Arab Republic?
Ensure brevity in your answer.  -6.40e+05. In the year 2001, what is the difference between the Aid flow (current US$) of Bulgaria and Aid flow (current US$) of Croatia?
Your answer should be very brief. 5.00e+04. In the year 2001, what is the difference between the Aid flow (current US$) in Bulgaria and Aid flow (current US$) in Georgia?
Your answer should be compact. 5.50e+05. In the year 2001, what is the difference between the Aid flow (current US$) in Croatia and Aid flow (current US$) in Georgia?
Keep it short and to the point. 5.00e+05. In the year 2001, what is the difference between the Aid flow (current US$) in Croatia and Aid flow (current US$) in Syrian Arab Republic?
Provide a succinct answer. -1.70e+05. In the year 2001, what is the difference between the Aid flow (current US$) of Georgia and Aid flow (current US$) of Syrian Arab Republic?
Provide a succinct answer. -6.70e+05. In the year 2002, what is the difference between the Aid flow (current US$) in Bulgaria and Aid flow (current US$) in Georgia?
Your response must be concise. 7.00e+04. In the year 2003, what is the difference between the Aid flow (current US$) of Bulgaria and Aid flow (current US$) of Georgia?
Keep it short and to the point. 6.00e+05. In the year 2003, what is the difference between the Aid flow (current US$) in Croatia and Aid flow (current US$) in Georgia?
Ensure brevity in your answer.  3.90e+05. In the year 2003, what is the difference between the Aid flow (current US$) in Croatia and Aid flow (current US$) in Syrian Arab Republic?
Offer a very short reply. -2.30e+05. In the year 2003, what is the difference between the Aid flow (current US$) in Georgia and Aid flow (current US$) in Syrian Arab Republic?
Your response must be concise. -6.20e+05. What is the ratio of the Aid flow (current US$) of Bulgaria in 1996 to that in 1997?
Offer a terse response. 0.56. What is the ratio of the Aid flow (current US$) of Croatia in 1996 to that in 1997?
Your answer should be very brief. 0.57. What is the ratio of the Aid flow (current US$) of Georgia in 1996 to that in 1997?
Ensure brevity in your answer.  0.23. What is the ratio of the Aid flow (current US$) in Syrian Arab Republic in 1996 to that in 1997?
Your response must be concise. 0.91. What is the ratio of the Aid flow (current US$) of Bulgaria in 1996 to that in 1998?
Your answer should be very brief. 0.09. What is the ratio of the Aid flow (current US$) of Croatia in 1996 to that in 1998?
Make the answer very short. 0.2. What is the ratio of the Aid flow (current US$) in Syrian Arab Republic in 1996 to that in 1998?
Your response must be concise. 0.64. What is the ratio of the Aid flow (current US$) of Bulgaria in 1996 to that in 1999?
Your response must be concise. 0.02. What is the ratio of the Aid flow (current US$) of Croatia in 1996 to that in 1999?
Your response must be concise. 0.72. What is the ratio of the Aid flow (current US$) in Georgia in 1996 to that in 1999?
Keep it short and to the point. 0.09. What is the ratio of the Aid flow (current US$) in Syrian Arab Republic in 1996 to that in 1999?
Ensure brevity in your answer.  0.47. What is the ratio of the Aid flow (current US$) of Bulgaria in 1996 to that in 2000?
Give a very brief answer. 0.03. What is the ratio of the Aid flow (current US$) of Syrian Arab Republic in 1996 to that in 2000?
Keep it short and to the point. 0.57. What is the ratio of the Aid flow (current US$) in Croatia in 1996 to that in 2001?
Your answer should be very brief. 0.47. What is the ratio of the Aid flow (current US$) of Syrian Arab Republic in 1996 to that in 2001?
Make the answer very short. 0.54. What is the ratio of the Aid flow (current US$) of Bulgaria in 1996 to that in 2002?
Keep it short and to the point. 0.17. What is the ratio of the Aid flow (current US$) in Croatia in 1996 to that in 2002?
Your answer should be very brief. 0.42. What is the ratio of the Aid flow (current US$) in Georgia in 1996 to that in 2002?
Provide a short and direct response. 0.07. What is the ratio of the Aid flow (current US$) in Syrian Arab Republic in 1996 to that in 2002?
Offer a terse response. 0.81. What is the ratio of the Aid flow (current US$) in Bulgaria in 1996 to that in 2003?
Offer a terse response. 0.13. What is the ratio of the Aid flow (current US$) of Croatia in 1996 to that in 2003?
Your answer should be compact. 0.55. What is the ratio of the Aid flow (current US$) of Syrian Arab Republic in 1996 to that in 2003?
Keep it short and to the point. 0.56. What is the ratio of the Aid flow (current US$) in Bulgaria in 1997 to that in 1998?
Provide a succinct answer. 0.16. What is the ratio of the Aid flow (current US$) in Croatia in 1997 to that in 1998?
Provide a short and direct response. 0.35. What is the ratio of the Aid flow (current US$) in Georgia in 1997 to that in 1998?
Provide a short and direct response. 1.44. What is the ratio of the Aid flow (current US$) in Syrian Arab Republic in 1997 to that in 1998?
Make the answer very short. 0.7. What is the ratio of the Aid flow (current US$) of Bulgaria in 1997 to that in 1999?
Offer a terse response. 0.04. What is the ratio of the Aid flow (current US$) in Croatia in 1997 to that in 1999?
Provide a succinct answer. 1.28. What is the ratio of the Aid flow (current US$) of Georgia in 1997 to that in 1999?
Keep it short and to the point. 0.39. What is the ratio of the Aid flow (current US$) of Syrian Arab Republic in 1997 to that in 1999?
Your response must be concise. 0.52. What is the ratio of the Aid flow (current US$) in Bulgaria in 1997 to that in 2000?
Offer a very short reply. 0.05. What is the ratio of the Aid flow (current US$) in Croatia in 1997 to that in 2000?
Offer a terse response. 1.7. What is the ratio of the Aid flow (current US$) in Georgia in 1997 to that in 2000?
Your answer should be compact. 2.6. What is the ratio of the Aid flow (current US$) in Syrian Arab Republic in 1997 to that in 2000?
Ensure brevity in your answer.  0.62. What is the ratio of the Aid flow (current US$) of Bulgaria in 1997 to that in 2001?
Make the answer very short. 0.27. What is the ratio of the Aid flow (current US$) of Croatia in 1997 to that in 2001?
Provide a short and direct response. 0.84. What is the ratio of the Aid flow (current US$) in Georgia in 1997 to that in 2001?
Your answer should be compact. 2.6. What is the ratio of the Aid flow (current US$) of Syrian Arab Republic in 1997 to that in 2001?
Make the answer very short. 0.6. What is the ratio of the Aid flow (current US$) of Bulgaria in 1997 to that in 2002?
Offer a very short reply. 0.3. What is the ratio of the Aid flow (current US$) in Croatia in 1997 to that in 2002?
Offer a terse response. 0.74. What is the ratio of the Aid flow (current US$) of Georgia in 1997 to that in 2002?
Provide a short and direct response. 0.28. What is the ratio of the Aid flow (current US$) in Syrian Arab Republic in 1997 to that in 2002?
Ensure brevity in your answer.  0.9. What is the ratio of the Aid flow (current US$) in Bulgaria in 1997 to that in 2003?
Your answer should be very brief. 0.24. What is the ratio of the Aid flow (current US$) of Croatia in 1997 to that in 2003?
Provide a short and direct response. 0.98. What is the ratio of the Aid flow (current US$) in Georgia in 1997 to that in 2003?
Make the answer very short. 1.62. What is the ratio of the Aid flow (current US$) in Syrian Arab Republic in 1997 to that in 2003?
Your answer should be compact. 0.61. What is the ratio of the Aid flow (current US$) in Bulgaria in 1998 to that in 1999?
Give a very brief answer. 0.23. What is the ratio of the Aid flow (current US$) in Croatia in 1998 to that in 1999?
Provide a succinct answer. 3.64. What is the ratio of the Aid flow (current US$) in Georgia in 1998 to that in 1999?
Offer a terse response. 0.27. What is the ratio of the Aid flow (current US$) of Syrian Arab Republic in 1998 to that in 1999?
Offer a terse response. 0.73. What is the ratio of the Aid flow (current US$) in Bulgaria in 1998 to that in 2000?
Your answer should be compact. 0.33. What is the ratio of the Aid flow (current US$) of Croatia in 1998 to that in 2000?
Make the answer very short. 4.85. What is the ratio of the Aid flow (current US$) of Syrian Arab Republic in 1998 to that in 2000?
Your answer should be very brief. 0.88. What is the ratio of the Aid flow (current US$) in Bulgaria in 1998 to that in 2001?
Your answer should be compact. 1.7. What is the ratio of the Aid flow (current US$) of Croatia in 1998 to that in 2001?
Your answer should be compact. 2.38. What is the ratio of the Aid flow (current US$) in Syrian Arab Republic in 1998 to that in 2001?
Give a very brief answer. 0.85. What is the ratio of the Aid flow (current US$) of Bulgaria in 1998 to that in 2002?
Provide a short and direct response. 1.92. What is the ratio of the Aid flow (current US$) in Croatia in 1998 to that in 2002?
Your answer should be compact. 2.11. What is the ratio of the Aid flow (current US$) in Georgia in 1998 to that in 2002?
Make the answer very short. 0.2. What is the ratio of the Aid flow (current US$) in Syrian Arab Republic in 1998 to that in 2002?
Your response must be concise. 1.27. What is the ratio of the Aid flow (current US$) of Croatia in 1998 to that in 2003?
Your answer should be very brief. 2.79. What is the ratio of the Aid flow (current US$) of Georgia in 1998 to that in 2003?
Your answer should be very brief. 1.12. What is the ratio of the Aid flow (current US$) of Syrian Arab Republic in 1998 to that in 2003?
Ensure brevity in your answer.  0.87. What is the ratio of the Aid flow (current US$) of Bulgaria in 1999 to that in 2000?
Keep it short and to the point. 1.45. What is the ratio of the Aid flow (current US$) of Croatia in 1999 to that in 2000?
Keep it short and to the point. 1.33. What is the ratio of the Aid flow (current US$) of Georgia in 1999 to that in 2000?
Provide a short and direct response. 6.6. What is the ratio of the Aid flow (current US$) of Syrian Arab Republic in 1999 to that in 2000?
Offer a terse response. 1.2. What is the ratio of the Aid flow (current US$) in Bulgaria in 1999 to that in 2001?
Your answer should be very brief. 7.38. What is the ratio of the Aid flow (current US$) of Croatia in 1999 to that in 2001?
Your response must be concise. 0.65. What is the ratio of the Aid flow (current US$) of Syrian Arab Republic in 1999 to that in 2001?
Your answer should be very brief. 1.15. What is the ratio of the Aid flow (current US$) in Bulgaria in 1999 to that in 2002?
Offer a very short reply. 8.36. What is the ratio of the Aid flow (current US$) of Croatia in 1999 to that in 2002?
Make the answer very short. 0.58. What is the ratio of the Aid flow (current US$) in Georgia in 1999 to that in 2002?
Provide a succinct answer. 0.72. What is the ratio of the Aid flow (current US$) in Syrian Arab Republic in 1999 to that in 2002?
Your answer should be very brief. 1.73. What is the ratio of the Aid flow (current US$) in Bulgaria in 1999 to that in 2003?
Your answer should be compact. 6.51. What is the ratio of the Aid flow (current US$) of Croatia in 1999 to that in 2003?
Your answer should be compact. 0.77. What is the ratio of the Aid flow (current US$) in Georgia in 1999 to that in 2003?
Ensure brevity in your answer.  4.12. What is the ratio of the Aid flow (current US$) of Syrian Arab Republic in 1999 to that in 2003?
Keep it short and to the point. 1.19. What is the ratio of the Aid flow (current US$) in Bulgaria in 2000 to that in 2001?
Your response must be concise. 5.08. What is the ratio of the Aid flow (current US$) of Croatia in 2000 to that in 2001?
Ensure brevity in your answer.  0.49. What is the ratio of the Aid flow (current US$) of Georgia in 2000 to that in 2001?
Keep it short and to the point. 1. What is the ratio of the Aid flow (current US$) in Bulgaria in 2000 to that in 2002?
Provide a short and direct response. 5.75. What is the ratio of the Aid flow (current US$) of Croatia in 2000 to that in 2002?
Offer a very short reply. 0.44. What is the ratio of the Aid flow (current US$) in Georgia in 2000 to that in 2002?
Offer a very short reply. 0.11. What is the ratio of the Aid flow (current US$) of Syrian Arab Republic in 2000 to that in 2002?
Your response must be concise. 1.44. What is the ratio of the Aid flow (current US$) in Bulgaria in 2000 to that in 2003?
Make the answer very short. 4.49. What is the ratio of the Aid flow (current US$) of Croatia in 2000 to that in 2003?
Provide a succinct answer. 0.57. What is the ratio of the Aid flow (current US$) of Syrian Arab Republic in 2000 to that in 2003?
Your answer should be compact. 0.99. What is the ratio of the Aid flow (current US$) of Bulgaria in 2001 to that in 2002?
Make the answer very short. 1.13. What is the ratio of the Aid flow (current US$) of Croatia in 2001 to that in 2002?
Offer a terse response. 0.89. What is the ratio of the Aid flow (current US$) in Georgia in 2001 to that in 2002?
Keep it short and to the point. 0.11. What is the ratio of the Aid flow (current US$) in Bulgaria in 2001 to that in 2003?
Your response must be concise. 0.88. What is the ratio of the Aid flow (current US$) of Croatia in 2001 to that in 2003?
Keep it short and to the point. 1.17. What is the ratio of the Aid flow (current US$) in Georgia in 2001 to that in 2003?
Your answer should be compact. 0.62. What is the ratio of the Aid flow (current US$) of Syrian Arab Republic in 2001 to that in 2003?
Offer a terse response. 1.03. What is the ratio of the Aid flow (current US$) in Bulgaria in 2002 to that in 2003?
Offer a very short reply. 0.78. What is the ratio of the Aid flow (current US$) in Croatia in 2002 to that in 2003?
Provide a succinct answer. 1.32. What is the ratio of the Aid flow (current US$) of Georgia in 2002 to that in 2003?
Your answer should be very brief. 5.75. What is the ratio of the Aid flow (current US$) in Syrian Arab Republic in 2002 to that in 2003?
Offer a terse response. 0.69. What is the difference between the highest and the second highest Aid flow (current US$) of Bulgaria?
Your answer should be compact. 1.38e+06. What is the difference between the highest and the second highest Aid flow (current US$) of Croatia?
Provide a short and direct response. 6.90e+05. What is the difference between the highest and the second highest Aid flow (current US$) of Georgia?
Your response must be concise. 1.30e+05. What is the difference between the highest and the second highest Aid flow (current US$) in Syrian Arab Republic?
Keep it short and to the point. 1.10e+05. What is the difference between the highest and the lowest Aid flow (current US$) in Bulgaria?
Ensure brevity in your answer.  4.34e+06. What is the difference between the highest and the lowest Aid flow (current US$) of Croatia?
Ensure brevity in your answer.  1.05e+06. What is the difference between the highest and the lowest Aid flow (current US$) in Georgia?
Offer a very short reply. 4.30e+05. 